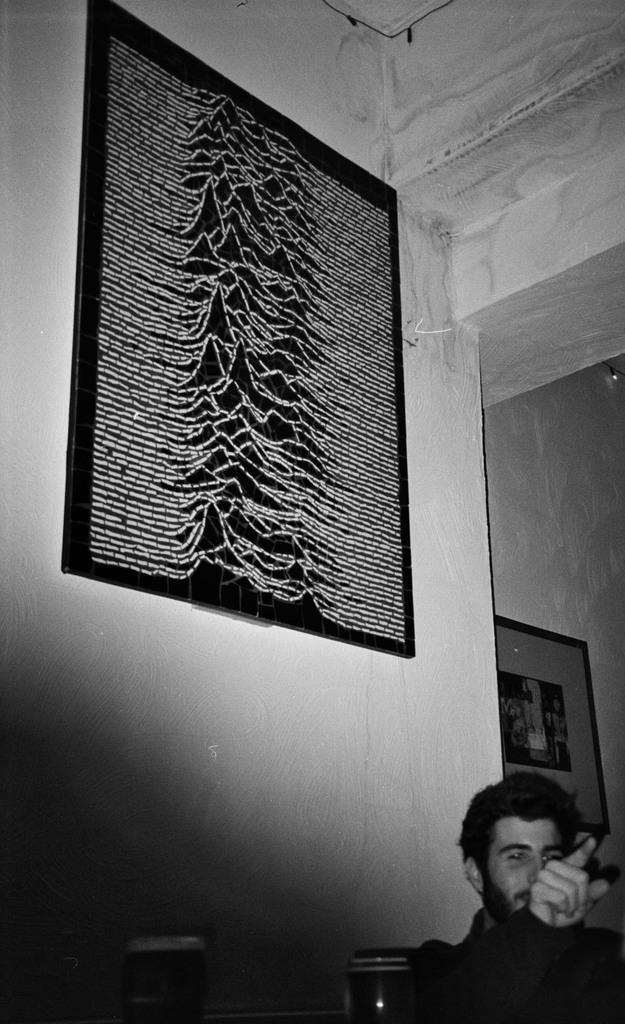Who is present in the image? There is a man in the image. Where is the man located in the image? The man is at the bottom side of the image. What can be seen on the wall in the image? There are portraits on the wall in the image. What type of pipe can be seen in the man's hand in the image? There is no pipe present in the man's hand or anywhere else in the image. 